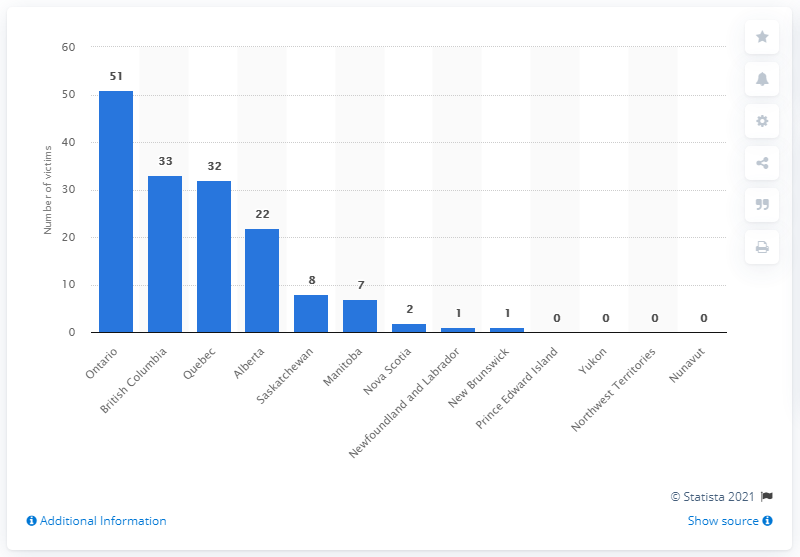Indicate a few pertinent items in this graphic. There were 51 gang-related homicides committed in Ontario in 2018. 